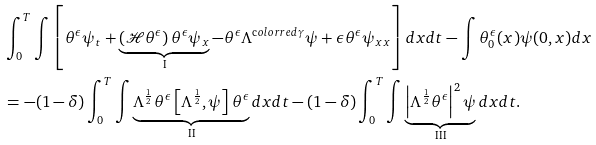Convert formula to latex. <formula><loc_0><loc_0><loc_500><loc_500>& \int ^ { T } _ { 0 } \int \left [ \theta ^ { \epsilon } \psi _ { t } + \underbrace { \left ( \mathcal { H } \theta ^ { \epsilon } \right ) \theta ^ { \epsilon } \psi _ { x } } _ { \text {I} } - \theta ^ { \epsilon } \Lambda ^ { \text  color{red} { \gamma } } \psi + \epsilon \theta ^ { \epsilon } \psi _ { x x } \right ] d x d t - \int \theta ^ { \epsilon } _ { 0 } ( x ) \psi ( 0 , x ) d x \\ & = - ( 1 - \delta ) \int ^ { T } _ { 0 } \int \underbrace { \Lambda ^ { \frac { 1 } { 2 } } \theta ^ { \epsilon } \left [ \Lambda ^ { \frac { 1 } { 2 } } , \psi \right ] \theta ^ { \epsilon } } _ { \text {II} } d x d t - ( 1 - \delta ) \int ^ { T } _ { 0 } \int \underbrace { \left | \Lambda ^ { \frac { 1 } { 2 } } \theta ^ { \epsilon } \right | ^ { 2 } \psi } _ { \text {III} } d x d t .</formula> 